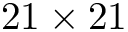Convert formula to latex. <formula><loc_0><loc_0><loc_500><loc_500>2 1 \times 2 1</formula> 